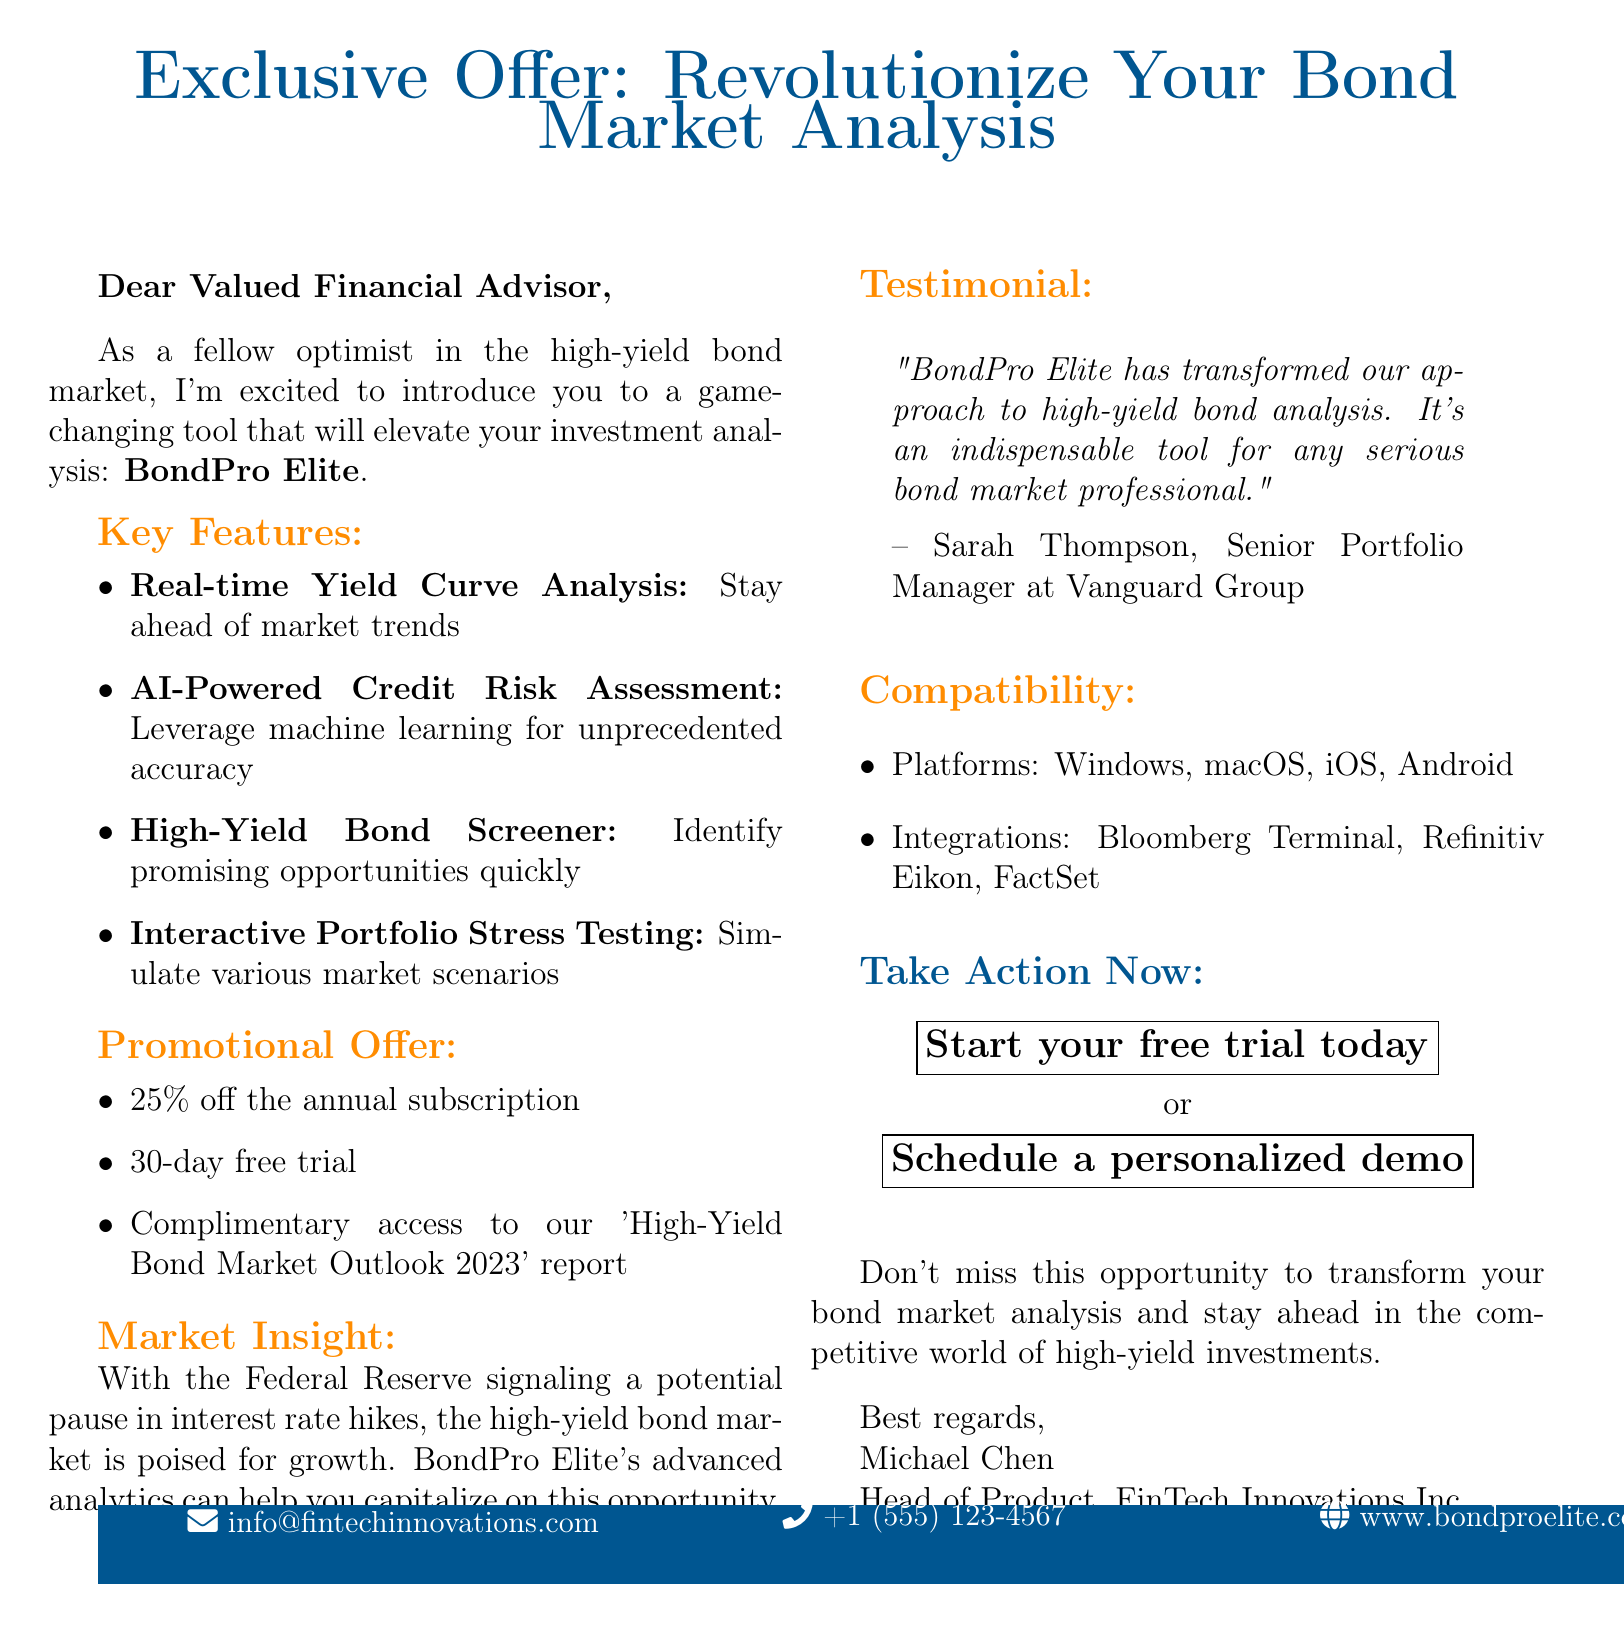What is the name of the software? The software being promoted is specifically named in the introduction of the document.
Answer: BondPro Elite Who is the developer of the software? The document provides the name of the company responsible for developing the software.
Answer: FinTech Innovations Inc What is the discount offered on the annual subscription? The promotional offer section mentions a specific percentage discount applicable on the subscription.
Answer: 25% off How long is the free trial period? The document states the duration of the trial offer available for potential users.
Answer: 30-day free trial What key feature allows for credit risk evaluation? The features section outlines several capabilities of the software, including one specifically related to credit risk.
Answer: AI-Powered Credit Risk Assessment How does BondPro Elite help with portfolio analysis? The document describes a specific feature that offers a simulation of market scenarios for bond portfolios.
Answer: Interactive Portfolio Stress Testing Who provided a testimonial for BondPro Elite? The testimonial section attributes a specific quote to a named individual in a relevant position.
Answer: Sarah Thompson What insight does the document provide about the current market? The market insight section discusses the potential growth in the high-yield bond market, contextualizing it within current economic indicators.
Answer: High-Yield Bond Market Outlook What platforms is BondPro Elite compatible with? The compatibility section lists several operating systems where the software can be used.
Answer: Windows, macOS, iOS, Android 